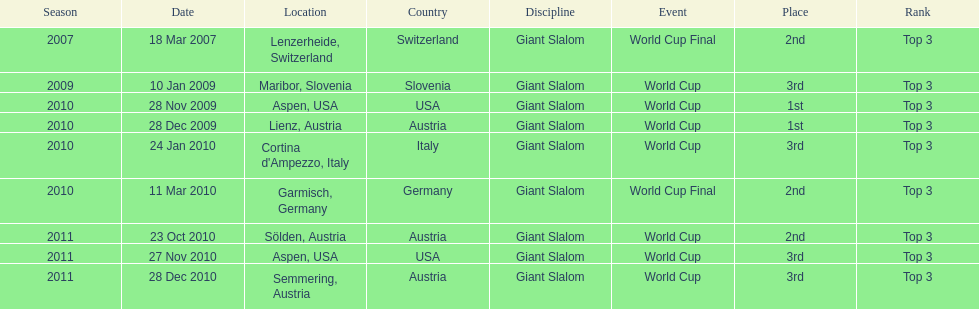What is the only location in the us? Aspen. 